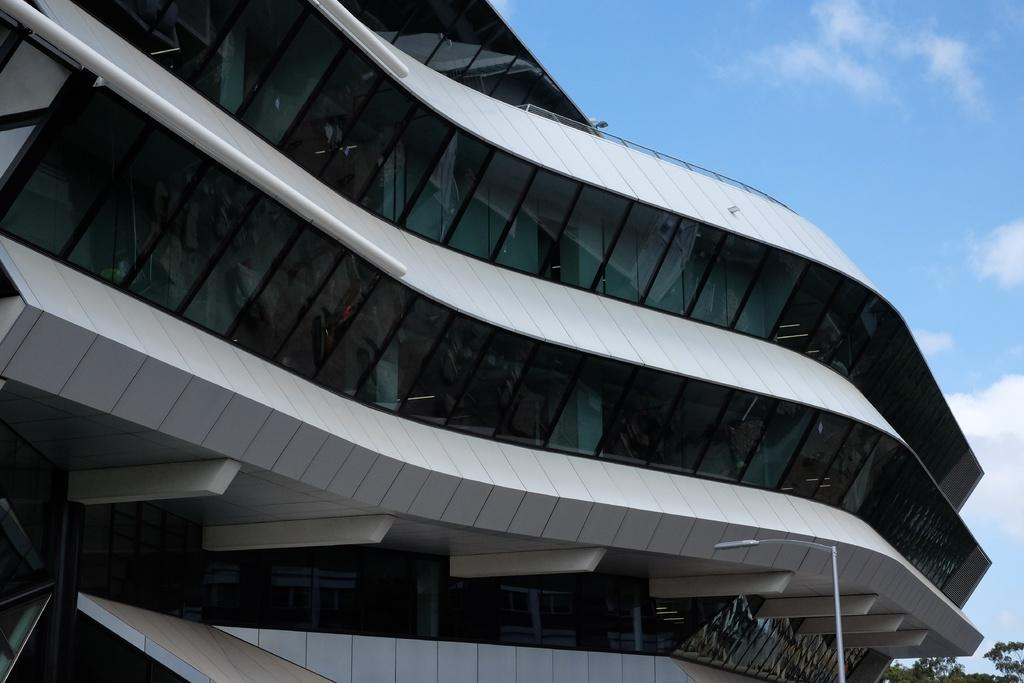What type of structure is present in the image? There is a building in the image. What else can be seen in the image besides the building? There is a pole and trees in the image. What is visible in the background of the image? The sky is visible in the background of the image. What can be observed in the sky? There are clouds in the sky. What type of jelly is being used to adjust the height of the pole in the image? There is no jelly present in the image, nor is there any adjustment being made to the pole. 